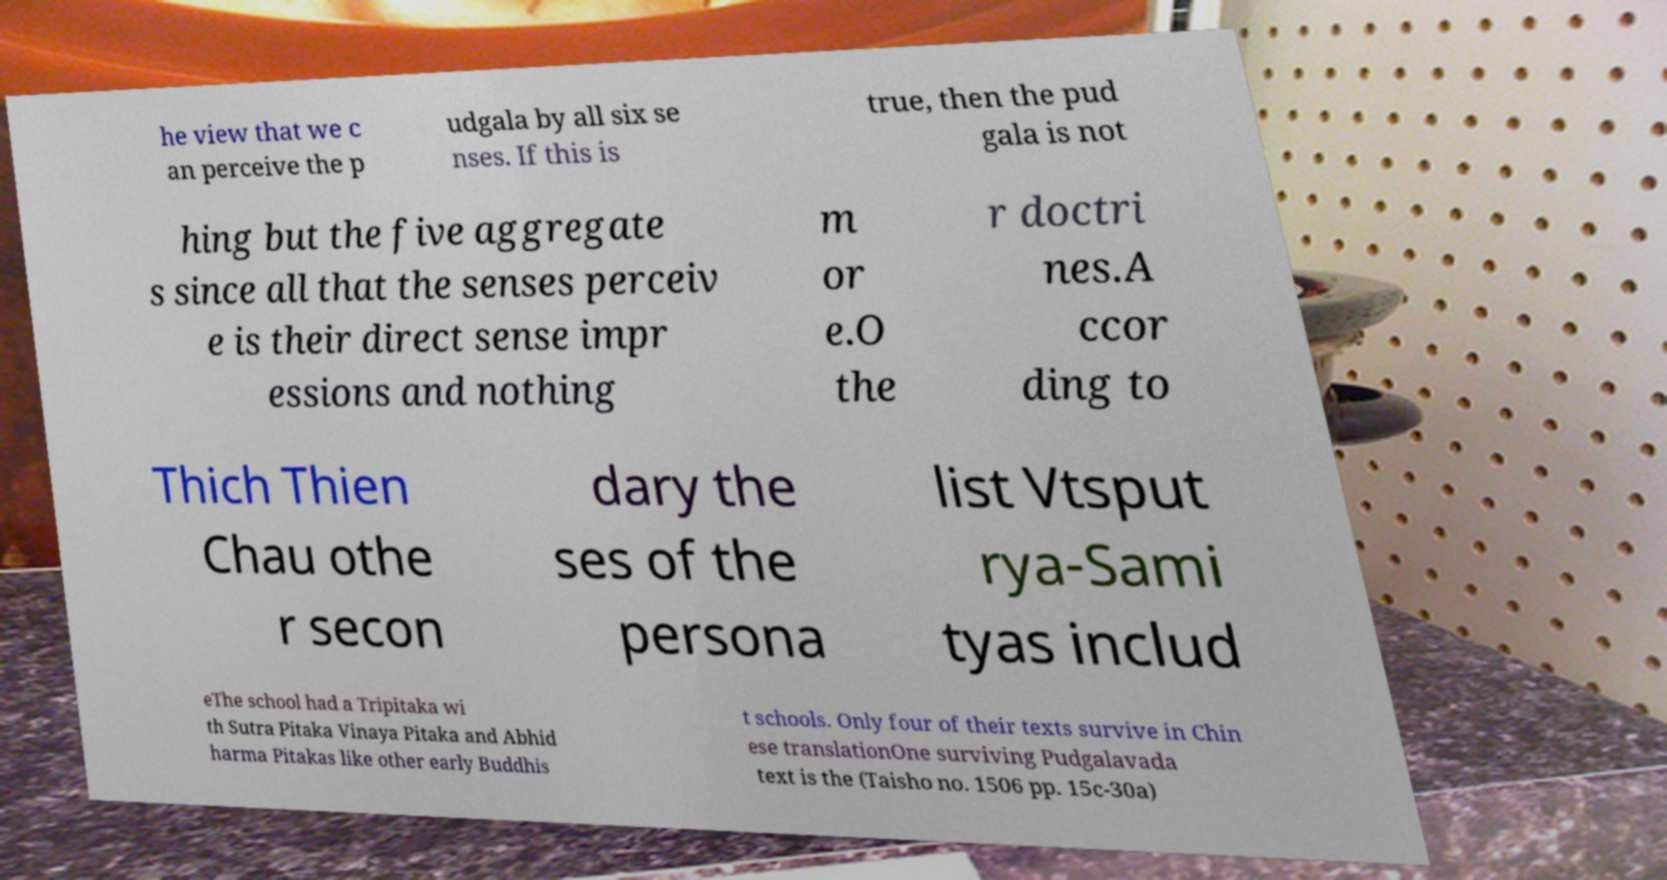Can you accurately transcribe the text from the provided image for me? he view that we c an perceive the p udgala by all six se nses. If this is true, then the pud gala is not hing but the five aggregate s since all that the senses perceiv e is their direct sense impr essions and nothing m or e.O the r doctri nes.A ccor ding to Thich Thien Chau othe r secon dary the ses of the persona list Vtsput rya-Sami tyas includ eThe school had a Tripitaka wi th Sutra Pitaka Vinaya Pitaka and Abhid harma Pitakas like other early Buddhis t schools. Only four of their texts survive in Chin ese translationOne surviving Pudgalavada text is the (Taisho no. 1506 pp. 15c-30a) 